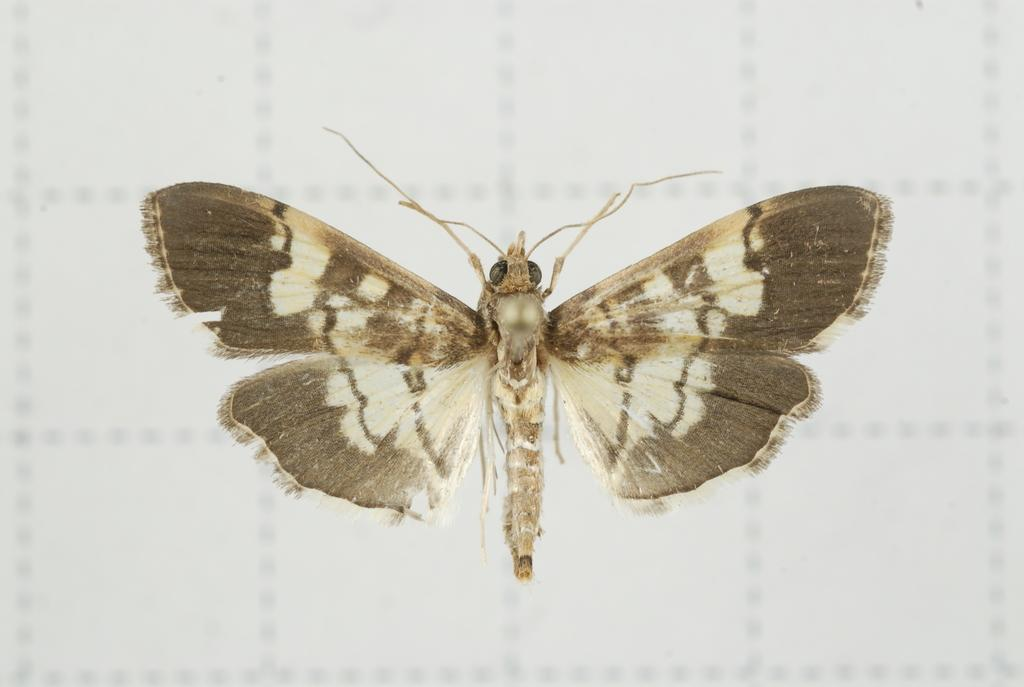What is the main subject of the picture? The main subject of the picture is a butterfly. What is the background of the picture? The background of the picture is white. What type of request is the butterfly making in the image? There is no indication in the image that the butterfly is making any request, as butterflies do not have the ability to communicate in this manner. 